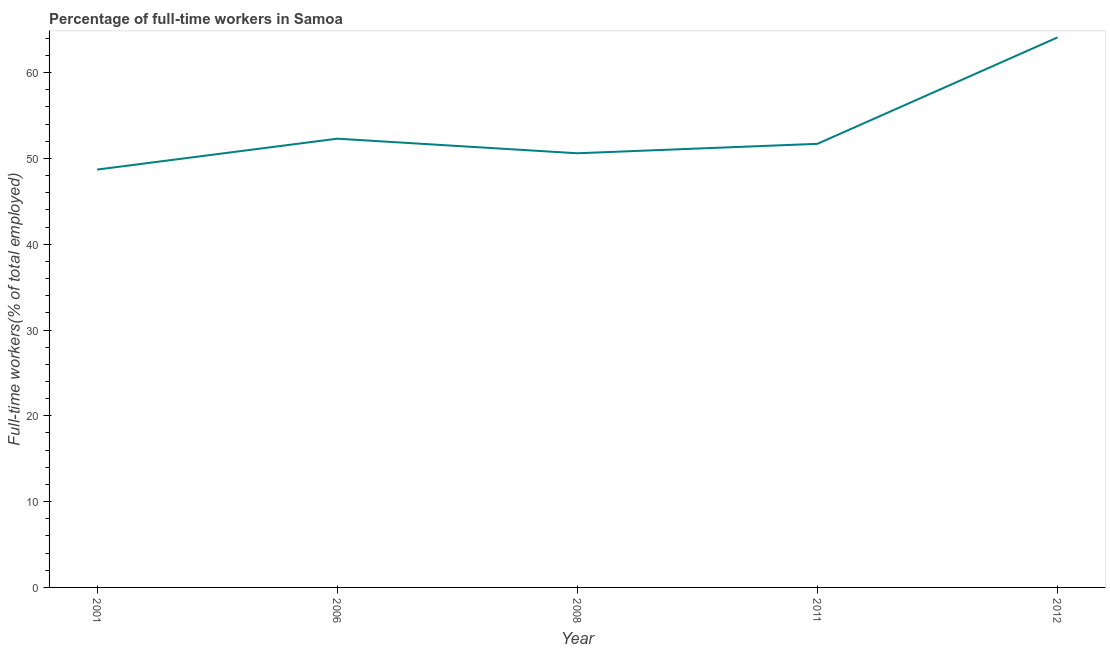What is the percentage of full-time workers in 2008?
Your answer should be compact. 50.6. Across all years, what is the maximum percentage of full-time workers?
Provide a short and direct response. 64.1. Across all years, what is the minimum percentage of full-time workers?
Your answer should be very brief. 48.7. In which year was the percentage of full-time workers maximum?
Keep it short and to the point. 2012. What is the sum of the percentage of full-time workers?
Give a very brief answer. 267.4. What is the difference between the percentage of full-time workers in 2001 and 2006?
Keep it short and to the point. -3.6. What is the average percentage of full-time workers per year?
Keep it short and to the point. 53.48. What is the median percentage of full-time workers?
Make the answer very short. 51.7. In how many years, is the percentage of full-time workers greater than 60 %?
Make the answer very short. 1. Do a majority of the years between 2011 and 2008 (inclusive) have percentage of full-time workers greater than 30 %?
Offer a very short reply. No. What is the ratio of the percentage of full-time workers in 2001 to that in 2008?
Provide a short and direct response. 0.96. Is the percentage of full-time workers in 2001 less than that in 2006?
Your answer should be compact. Yes. Is the difference between the percentage of full-time workers in 2006 and 2011 greater than the difference between any two years?
Provide a succinct answer. No. What is the difference between the highest and the second highest percentage of full-time workers?
Make the answer very short. 11.8. What is the difference between the highest and the lowest percentage of full-time workers?
Make the answer very short. 15.4. Does the percentage of full-time workers monotonically increase over the years?
Ensure brevity in your answer.  No. Are the values on the major ticks of Y-axis written in scientific E-notation?
Keep it short and to the point. No. Does the graph contain grids?
Your answer should be compact. No. What is the title of the graph?
Give a very brief answer. Percentage of full-time workers in Samoa. What is the label or title of the X-axis?
Ensure brevity in your answer.  Year. What is the label or title of the Y-axis?
Make the answer very short. Full-time workers(% of total employed). What is the Full-time workers(% of total employed) of 2001?
Give a very brief answer. 48.7. What is the Full-time workers(% of total employed) of 2006?
Give a very brief answer. 52.3. What is the Full-time workers(% of total employed) of 2008?
Your response must be concise. 50.6. What is the Full-time workers(% of total employed) in 2011?
Offer a terse response. 51.7. What is the Full-time workers(% of total employed) in 2012?
Your answer should be compact. 64.1. What is the difference between the Full-time workers(% of total employed) in 2001 and 2006?
Your response must be concise. -3.6. What is the difference between the Full-time workers(% of total employed) in 2001 and 2008?
Give a very brief answer. -1.9. What is the difference between the Full-time workers(% of total employed) in 2001 and 2011?
Give a very brief answer. -3. What is the difference between the Full-time workers(% of total employed) in 2001 and 2012?
Offer a terse response. -15.4. What is the difference between the Full-time workers(% of total employed) in 2006 and 2012?
Your response must be concise. -11.8. What is the difference between the Full-time workers(% of total employed) in 2011 and 2012?
Make the answer very short. -12.4. What is the ratio of the Full-time workers(% of total employed) in 2001 to that in 2006?
Ensure brevity in your answer.  0.93. What is the ratio of the Full-time workers(% of total employed) in 2001 to that in 2011?
Provide a short and direct response. 0.94. What is the ratio of the Full-time workers(% of total employed) in 2001 to that in 2012?
Provide a short and direct response. 0.76. What is the ratio of the Full-time workers(% of total employed) in 2006 to that in 2008?
Ensure brevity in your answer.  1.03. What is the ratio of the Full-time workers(% of total employed) in 2006 to that in 2011?
Ensure brevity in your answer.  1.01. What is the ratio of the Full-time workers(% of total employed) in 2006 to that in 2012?
Ensure brevity in your answer.  0.82. What is the ratio of the Full-time workers(% of total employed) in 2008 to that in 2011?
Give a very brief answer. 0.98. What is the ratio of the Full-time workers(% of total employed) in 2008 to that in 2012?
Make the answer very short. 0.79. What is the ratio of the Full-time workers(% of total employed) in 2011 to that in 2012?
Make the answer very short. 0.81. 